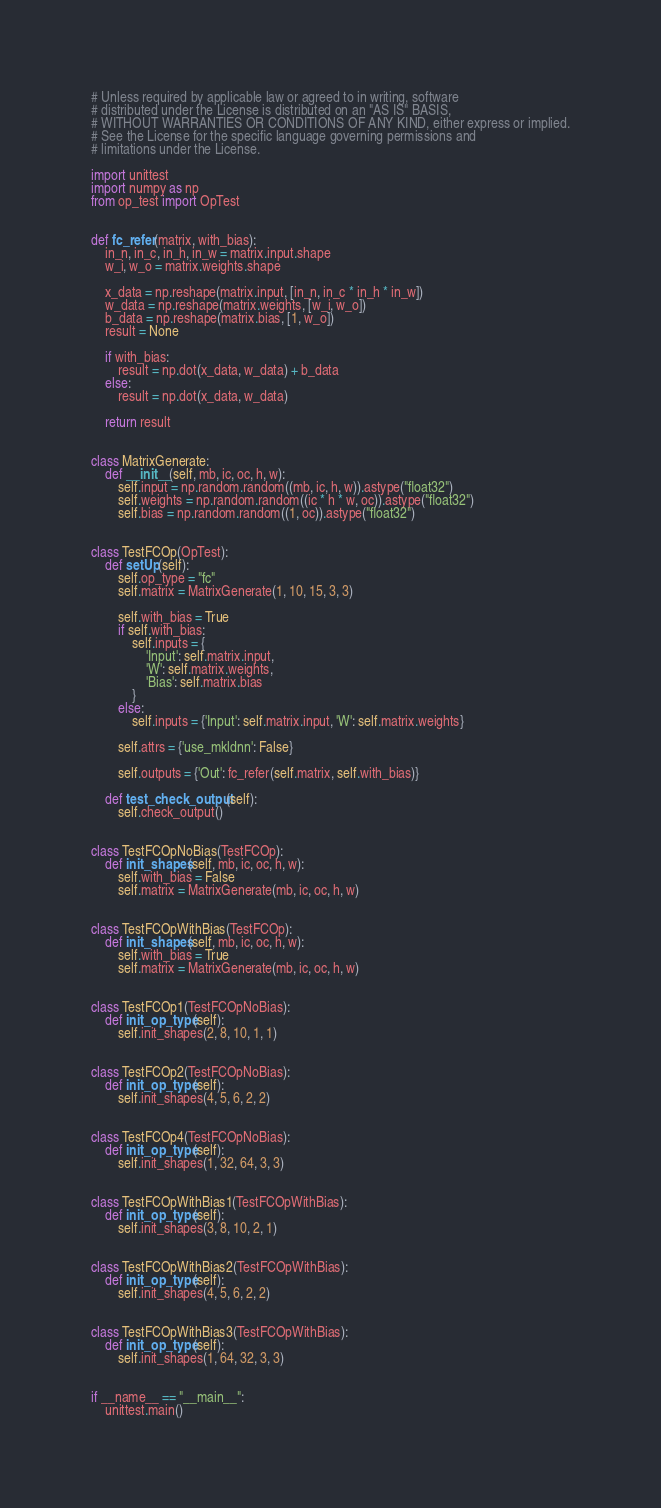Convert code to text. <code><loc_0><loc_0><loc_500><loc_500><_Python_># Unless required by applicable law or agreed to in writing, software
# distributed under the License is distributed on an "AS IS" BASIS,
# WITHOUT WARRANTIES OR CONDITIONS OF ANY KIND, either express or implied.
# See the License for the specific language governing permissions and
# limitations under the License.

import unittest
import numpy as np
from op_test import OpTest


def fc_refer(matrix, with_bias):
    in_n, in_c, in_h, in_w = matrix.input.shape
    w_i, w_o = matrix.weights.shape

    x_data = np.reshape(matrix.input, [in_n, in_c * in_h * in_w])
    w_data = np.reshape(matrix.weights, [w_i, w_o])
    b_data = np.reshape(matrix.bias, [1, w_o])
    result = None

    if with_bias:
        result = np.dot(x_data, w_data) + b_data
    else:
        result = np.dot(x_data, w_data)

    return result


class MatrixGenerate:
    def __init__(self, mb, ic, oc, h, w):
        self.input = np.random.random((mb, ic, h, w)).astype("float32")
        self.weights = np.random.random((ic * h * w, oc)).astype("float32")
        self.bias = np.random.random((1, oc)).astype("float32")


class TestFCOp(OpTest):
    def setUp(self):
        self.op_type = "fc"
        self.matrix = MatrixGenerate(1, 10, 15, 3, 3)

        self.with_bias = True
        if self.with_bias:
            self.inputs = {
                'Input': self.matrix.input,
                'W': self.matrix.weights,
                'Bias': self.matrix.bias
            }
        else:
            self.inputs = {'Input': self.matrix.input, 'W': self.matrix.weights}

        self.attrs = {'use_mkldnn': False}

        self.outputs = {'Out': fc_refer(self.matrix, self.with_bias)}

    def test_check_output(self):
        self.check_output()


class TestFCOpNoBias(TestFCOp):
    def init_shapes(self, mb, ic, oc, h, w):
        self.with_bias = False
        self.matrix = MatrixGenerate(mb, ic, oc, h, w)


class TestFCOpWithBias(TestFCOp):
    def init_shapes(self, mb, ic, oc, h, w):
        self.with_bias = True
        self.matrix = MatrixGenerate(mb, ic, oc, h, w)


class TestFCOp1(TestFCOpNoBias):
    def init_op_type(self):
        self.init_shapes(2, 8, 10, 1, 1)


class TestFCOp2(TestFCOpNoBias):
    def init_op_type(self):
        self.init_shapes(4, 5, 6, 2, 2)


class TestFCOp4(TestFCOpNoBias):
    def init_op_type(self):
        self.init_shapes(1, 32, 64, 3, 3)


class TestFCOpWithBias1(TestFCOpWithBias):
    def init_op_type(self):
        self.init_shapes(3, 8, 10, 2, 1)


class TestFCOpWithBias2(TestFCOpWithBias):
    def init_op_type(self):
        self.init_shapes(4, 5, 6, 2, 2)


class TestFCOpWithBias3(TestFCOpWithBias):
    def init_op_type(self):
        self.init_shapes(1, 64, 32, 3, 3)


if __name__ == "__main__":
    unittest.main()
</code> 